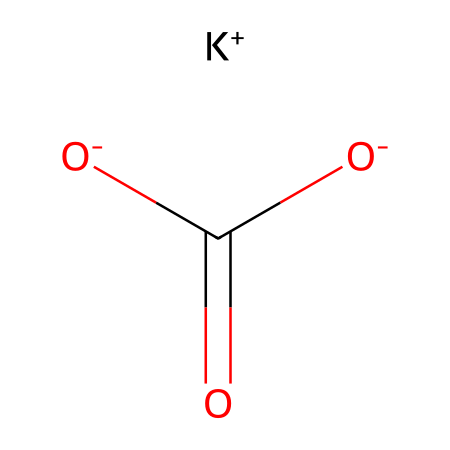What is the total number of atoms in this compound? The compound represented includes potassium (K), carbon (C), oxygen (O), and hydrogen (H) atoms. Analyzing the SMILES, we see one potassium atom, one carbon atom, three oxygen atoms, and one hydrogen atom, leading to a total of six atoms.
Answer: six How many distinct elements are present in this electrolyte? The SMILES representation indicates the presence of potassium (K), carbon (C), oxygen (O), and hydrogen (H). Counting these, we find four distinct elements in total.
Answer: four What type of ion is present in this compound? The SMILES shows the presence of a potassium ion (K+), which indicates that this compound includes a positively charged ion as part of its structure.
Answer: potassium ion What does the presence of the carboxylate group indicate about this compound? The carboxylate group (–COO–) indicates that this compound can act as a weak acid or base. In the context of electrolytes, it suggests it can dissociate in water, releasing ions.
Answer: weak acid/base How does the molecular structure suggest it can conduct electricity? The presence of charged ions, specifically the potassium ion (K+) and the presence of carboxylate ions, allows for the movement of ions in solution. This ion mobility is essential for electrical conductivity in electrolytes.
Answer: ion mobility What effect does potassium bicarbonate have on the pH level of coconut water? Potassium bicarbonate can act as a buffering agent, helping to stabilize pH levels in the solution. When dissolved, it can neutralize excess acids, suggesting it may raise the pH if the solution is too acidic.
Answer: raises pH How many oxygen atoms are in the compound? By observing the SMILES, we see three oxygen atoms identified by the notation and chemical bonds. Therefore, this compound contains three oxygen atoms.
Answer: three 